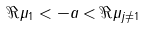<formula> <loc_0><loc_0><loc_500><loc_500>\Re \mu _ { 1 } < - a < \Re \mu _ { j \neq 1 }</formula> 